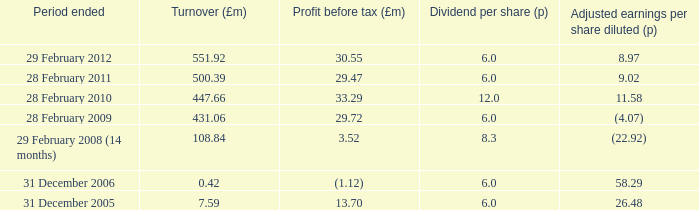47? 500.39. 